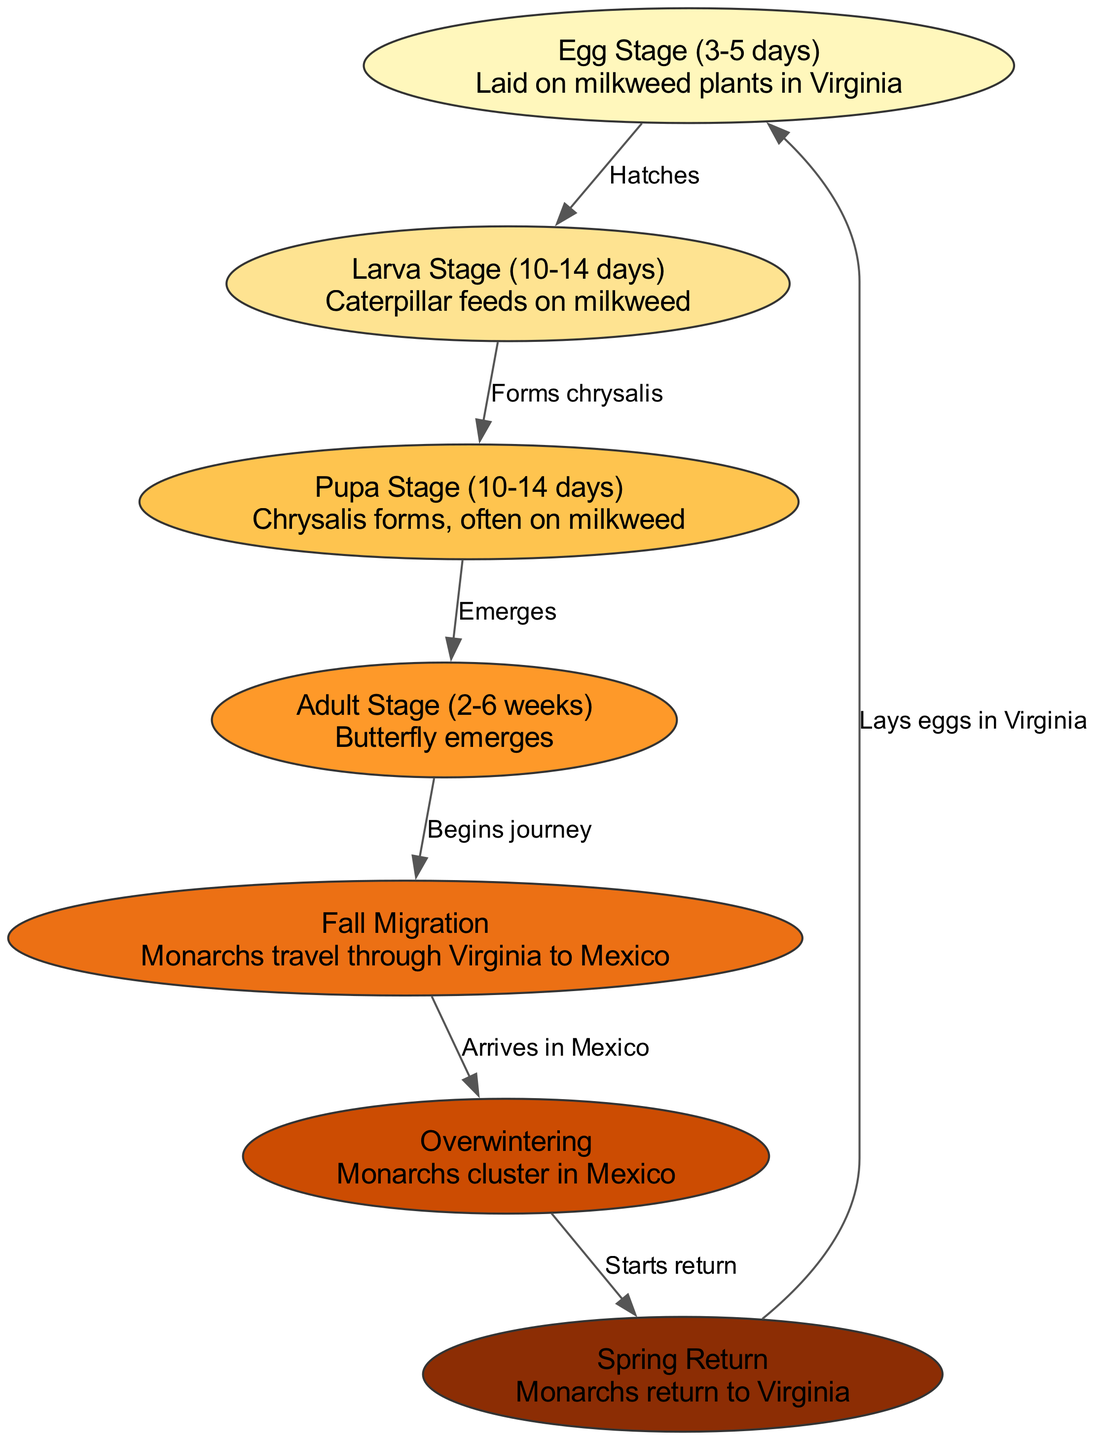What is the duration of the egg stage? The diagram indicates that the egg stage lasts between 3 to 5 days. This information is found under the "Egg Stage" node, which provides details about the duration of this lifecycle stage.
Answer: 3-5 days How many stages are there in the monarch butterfly lifecycle? By counting the nodes in the diagram, we see there are seven distinct stages in the lifecycle, identified as egg, larva, pupa, adult, migration, overwintering, and spring return.
Answer: 7 What is the initial stage of the lifecycle? The diagram's flow starts with the "Egg Stage," which is the first node in the lifecycle sequence, indicating that this is where the lifecycle begins.
Answer: Egg Stage What happens after the larva stage? According to the edges connecting the nodes, after the larva stage, the caterpillar forms a chrysalis, which leads to the pupa stage. This relationship is shown by the edge labeled "Forms chrysalis."
Answer: Forms chrysalis What do monarchs do during fall migration? The diagram describes the "Fall Migration" stage, stating that monarchs travel through Virginia to migrate toward Mexico. This is a key movement represented in the lifecycle.
Answer: Travel through Virginia to Mexico Which stage occurs after overwintering? The diagram shows that following the "Overwintering" stage, the monarchs start their return in the "Spring Return" stage. This is indicated by the connection leading from overwintering to spring return.
Answer: Spring Return What is the last step before laying eggs in Virginia? The diagram illustrates that the last step prior to laying eggs is the adult stage, where the butterfly emerges after the pupa stage. The edge labeled "Emerges" connects these two stages.
Answer: Adult Stage Where do monarchs cluster during overwintering? The "Overwintering" node specifically states that monarchs cluster in Mexico, indicating their primary location during this phase of their lifecycle.
Answer: Mexico 